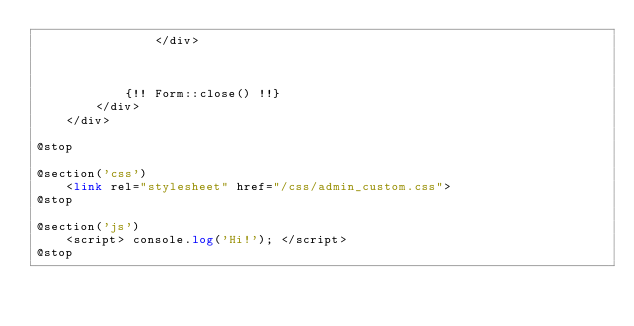<code> <loc_0><loc_0><loc_500><loc_500><_PHP_>                </div>
    
            

            {!! Form::close() !!}
        </div>
    </div>

@stop

@section('css')
    <link rel="stylesheet" href="/css/admin_custom.css">
@stop

@section('js')
    <script> console.log('Hi!'); </script>
@stop</code> 